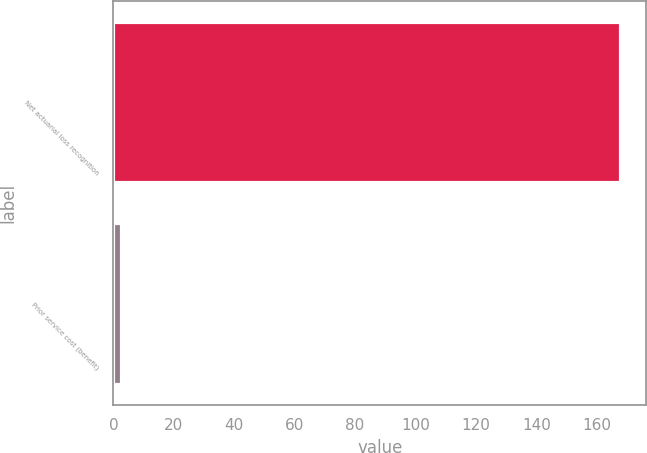Convert chart to OTSL. <chart><loc_0><loc_0><loc_500><loc_500><bar_chart><fcel>Net actuarial loss recognition<fcel>Prior service cost (benefit)<nl><fcel>168<fcel>3<nl></chart> 